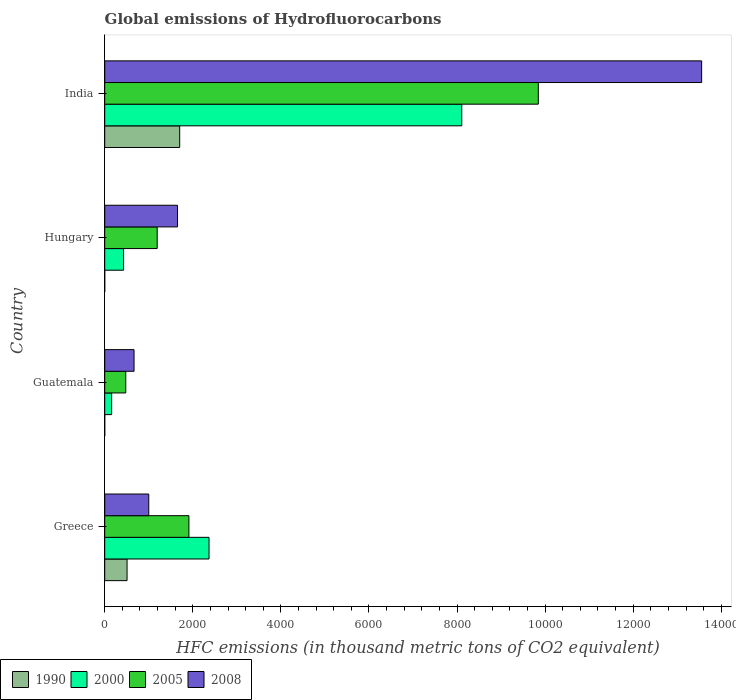How many bars are there on the 3rd tick from the top?
Offer a very short reply. 4. How many bars are there on the 2nd tick from the bottom?
Offer a terse response. 4. In how many cases, is the number of bars for a given country not equal to the number of legend labels?
Your answer should be very brief. 0. What is the global emissions of Hydrofluorocarbons in 2000 in Guatemala?
Offer a very short reply. 157.6. Across all countries, what is the maximum global emissions of Hydrofluorocarbons in 2008?
Keep it short and to the point. 1.36e+04. Across all countries, what is the minimum global emissions of Hydrofluorocarbons in 2005?
Your response must be concise. 477.8. In which country was the global emissions of Hydrofluorocarbons in 2008 maximum?
Give a very brief answer. India. In which country was the global emissions of Hydrofluorocarbons in 2000 minimum?
Offer a terse response. Guatemala. What is the total global emissions of Hydrofluorocarbons in 1990 in the graph?
Your response must be concise. 2209.5. What is the difference between the global emissions of Hydrofluorocarbons in 2005 in Hungary and that in India?
Keep it short and to the point. -8653.8. What is the difference between the global emissions of Hydrofluorocarbons in 2008 in Guatemala and the global emissions of Hydrofluorocarbons in 2000 in Hungary?
Provide a short and direct response. 237.6. What is the average global emissions of Hydrofluorocarbons in 2000 per country?
Offer a very short reply. 2765.35. What is the difference between the global emissions of Hydrofluorocarbons in 2000 and global emissions of Hydrofluorocarbons in 2005 in India?
Your response must be concise. -1738. In how many countries, is the global emissions of Hydrofluorocarbons in 2005 greater than 6000 thousand metric tons?
Your answer should be very brief. 1. What is the ratio of the global emissions of Hydrofluorocarbons in 2008 in Greece to that in Guatemala?
Your answer should be compact. 1.5. Is the global emissions of Hydrofluorocarbons in 1990 in Greece less than that in Hungary?
Make the answer very short. No. What is the difference between the highest and the second highest global emissions of Hydrofluorocarbons in 2000?
Offer a very short reply. 5738.8. What is the difference between the highest and the lowest global emissions of Hydrofluorocarbons in 2000?
Your answer should be very brief. 7949.6. In how many countries, is the global emissions of Hydrofluorocarbons in 2005 greater than the average global emissions of Hydrofluorocarbons in 2005 taken over all countries?
Ensure brevity in your answer.  1. Is the sum of the global emissions of Hydrofluorocarbons in 2005 in Greece and Guatemala greater than the maximum global emissions of Hydrofluorocarbons in 1990 across all countries?
Ensure brevity in your answer.  Yes. What does the 4th bar from the bottom in India represents?
Your response must be concise. 2008. Is it the case that in every country, the sum of the global emissions of Hydrofluorocarbons in 2005 and global emissions of Hydrofluorocarbons in 2008 is greater than the global emissions of Hydrofluorocarbons in 2000?
Give a very brief answer. Yes. How many bars are there?
Offer a terse response. 16. Are all the bars in the graph horizontal?
Your answer should be compact. Yes. How many countries are there in the graph?
Provide a short and direct response. 4. What is the difference between two consecutive major ticks on the X-axis?
Offer a very short reply. 2000. Are the values on the major ticks of X-axis written in scientific E-notation?
Make the answer very short. No. How many legend labels are there?
Ensure brevity in your answer.  4. How are the legend labels stacked?
Ensure brevity in your answer.  Horizontal. What is the title of the graph?
Offer a very short reply. Global emissions of Hydrofluorocarbons. What is the label or title of the X-axis?
Ensure brevity in your answer.  HFC emissions (in thousand metric tons of CO2 equivalent). What is the label or title of the Y-axis?
Your response must be concise. Country. What is the HFC emissions (in thousand metric tons of CO2 equivalent) in 1990 in Greece?
Your answer should be compact. 507.2. What is the HFC emissions (in thousand metric tons of CO2 equivalent) in 2000 in Greece?
Your answer should be very brief. 2368.4. What is the HFC emissions (in thousand metric tons of CO2 equivalent) in 2005 in Greece?
Provide a succinct answer. 1911.4. What is the HFC emissions (in thousand metric tons of CO2 equivalent) in 2008 in Greece?
Make the answer very short. 1000.3. What is the HFC emissions (in thousand metric tons of CO2 equivalent) of 1990 in Guatemala?
Provide a short and direct response. 0.1. What is the HFC emissions (in thousand metric tons of CO2 equivalent) in 2000 in Guatemala?
Keep it short and to the point. 157.6. What is the HFC emissions (in thousand metric tons of CO2 equivalent) in 2005 in Guatemala?
Your response must be concise. 477.8. What is the HFC emissions (in thousand metric tons of CO2 equivalent) in 2008 in Guatemala?
Make the answer very short. 665.8. What is the HFC emissions (in thousand metric tons of CO2 equivalent) of 2000 in Hungary?
Offer a terse response. 428.2. What is the HFC emissions (in thousand metric tons of CO2 equivalent) in 2005 in Hungary?
Keep it short and to the point. 1191.4. What is the HFC emissions (in thousand metric tons of CO2 equivalent) of 2008 in Hungary?
Your response must be concise. 1652.9. What is the HFC emissions (in thousand metric tons of CO2 equivalent) of 1990 in India?
Give a very brief answer. 1702.1. What is the HFC emissions (in thousand metric tons of CO2 equivalent) of 2000 in India?
Your answer should be very brief. 8107.2. What is the HFC emissions (in thousand metric tons of CO2 equivalent) of 2005 in India?
Your response must be concise. 9845.2. What is the HFC emissions (in thousand metric tons of CO2 equivalent) in 2008 in India?
Your answer should be compact. 1.36e+04. Across all countries, what is the maximum HFC emissions (in thousand metric tons of CO2 equivalent) in 1990?
Give a very brief answer. 1702.1. Across all countries, what is the maximum HFC emissions (in thousand metric tons of CO2 equivalent) of 2000?
Your response must be concise. 8107.2. Across all countries, what is the maximum HFC emissions (in thousand metric tons of CO2 equivalent) of 2005?
Your response must be concise. 9845.2. Across all countries, what is the maximum HFC emissions (in thousand metric tons of CO2 equivalent) in 2008?
Offer a terse response. 1.36e+04. Across all countries, what is the minimum HFC emissions (in thousand metric tons of CO2 equivalent) in 2000?
Your answer should be very brief. 157.6. Across all countries, what is the minimum HFC emissions (in thousand metric tons of CO2 equivalent) in 2005?
Offer a very short reply. 477.8. Across all countries, what is the minimum HFC emissions (in thousand metric tons of CO2 equivalent) in 2008?
Offer a very short reply. 665.8. What is the total HFC emissions (in thousand metric tons of CO2 equivalent) of 1990 in the graph?
Your answer should be compact. 2209.5. What is the total HFC emissions (in thousand metric tons of CO2 equivalent) in 2000 in the graph?
Your response must be concise. 1.11e+04. What is the total HFC emissions (in thousand metric tons of CO2 equivalent) in 2005 in the graph?
Ensure brevity in your answer.  1.34e+04. What is the total HFC emissions (in thousand metric tons of CO2 equivalent) in 2008 in the graph?
Provide a short and direct response. 1.69e+04. What is the difference between the HFC emissions (in thousand metric tons of CO2 equivalent) of 1990 in Greece and that in Guatemala?
Offer a very short reply. 507.1. What is the difference between the HFC emissions (in thousand metric tons of CO2 equivalent) of 2000 in Greece and that in Guatemala?
Offer a very short reply. 2210.8. What is the difference between the HFC emissions (in thousand metric tons of CO2 equivalent) of 2005 in Greece and that in Guatemala?
Your answer should be very brief. 1433.6. What is the difference between the HFC emissions (in thousand metric tons of CO2 equivalent) of 2008 in Greece and that in Guatemala?
Keep it short and to the point. 334.5. What is the difference between the HFC emissions (in thousand metric tons of CO2 equivalent) in 1990 in Greece and that in Hungary?
Offer a very short reply. 507.1. What is the difference between the HFC emissions (in thousand metric tons of CO2 equivalent) in 2000 in Greece and that in Hungary?
Ensure brevity in your answer.  1940.2. What is the difference between the HFC emissions (in thousand metric tons of CO2 equivalent) of 2005 in Greece and that in Hungary?
Your answer should be very brief. 720. What is the difference between the HFC emissions (in thousand metric tons of CO2 equivalent) in 2008 in Greece and that in Hungary?
Offer a very short reply. -652.6. What is the difference between the HFC emissions (in thousand metric tons of CO2 equivalent) in 1990 in Greece and that in India?
Your response must be concise. -1194.9. What is the difference between the HFC emissions (in thousand metric tons of CO2 equivalent) of 2000 in Greece and that in India?
Ensure brevity in your answer.  -5738.8. What is the difference between the HFC emissions (in thousand metric tons of CO2 equivalent) of 2005 in Greece and that in India?
Give a very brief answer. -7933.8. What is the difference between the HFC emissions (in thousand metric tons of CO2 equivalent) of 2008 in Greece and that in India?
Offer a terse response. -1.26e+04. What is the difference between the HFC emissions (in thousand metric tons of CO2 equivalent) of 1990 in Guatemala and that in Hungary?
Provide a succinct answer. 0. What is the difference between the HFC emissions (in thousand metric tons of CO2 equivalent) in 2000 in Guatemala and that in Hungary?
Make the answer very short. -270.6. What is the difference between the HFC emissions (in thousand metric tons of CO2 equivalent) of 2005 in Guatemala and that in Hungary?
Offer a very short reply. -713.6. What is the difference between the HFC emissions (in thousand metric tons of CO2 equivalent) in 2008 in Guatemala and that in Hungary?
Your response must be concise. -987.1. What is the difference between the HFC emissions (in thousand metric tons of CO2 equivalent) of 1990 in Guatemala and that in India?
Provide a short and direct response. -1702. What is the difference between the HFC emissions (in thousand metric tons of CO2 equivalent) of 2000 in Guatemala and that in India?
Make the answer very short. -7949.6. What is the difference between the HFC emissions (in thousand metric tons of CO2 equivalent) of 2005 in Guatemala and that in India?
Provide a succinct answer. -9367.4. What is the difference between the HFC emissions (in thousand metric tons of CO2 equivalent) in 2008 in Guatemala and that in India?
Provide a succinct answer. -1.29e+04. What is the difference between the HFC emissions (in thousand metric tons of CO2 equivalent) of 1990 in Hungary and that in India?
Ensure brevity in your answer.  -1702. What is the difference between the HFC emissions (in thousand metric tons of CO2 equivalent) in 2000 in Hungary and that in India?
Make the answer very short. -7679. What is the difference between the HFC emissions (in thousand metric tons of CO2 equivalent) of 2005 in Hungary and that in India?
Keep it short and to the point. -8653.8. What is the difference between the HFC emissions (in thousand metric tons of CO2 equivalent) of 2008 in Hungary and that in India?
Keep it short and to the point. -1.19e+04. What is the difference between the HFC emissions (in thousand metric tons of CO2 equivalent) of 1990 in Greece and the HFC emissions (in thousand metric tons of CO2 equivalent) of 2000 in Guatemala?
Keep it short and to the point. 349.6. What is the difference between the HFC emissions (in thousand metric tons of CO2 equivalent) in 1990 in Greece and the HFC emissions (in thousand metric tons of CO2 equivalent) in 2005 in Guatemala?
Make the answer very short. 29.4. What is the difference between the HFC emissions (in thousand metric tons of CO2 equivalent) of 1990 in Greece and the HFC emissions (in thousand metric tons of CO2 equivalent) of 2008 in Guatemala?
Keep it short and to the point. -158.6. What is the difference between the HFC emissions (in thousand metric tons of CO2 equivalent) in 2000 in Greece and the HFC emissions (in thousand metric tons of CO2 equivalent) in 2005 in Guatemala?
Keep it short and to the point. 1890.6. What is the difference between the HFC emissions (in thousand metric tons of CO2 equivalent) in 2000 in Greece and the HFC emissions (in thousand metric tons of CO2 equivalent) in 2008 in Guatemala?
Your answer should be compact. 1702.6. What is the difference between the HFC emissions (in thousand metric tons of CO2 equivalent) of 2005 in Greece and the HFC emissions (in thousand metric tons of CO2 equivalent) of 2008 in Guatemala?
Provide a succinct answer. 1245.6. What is the difference between the HFC emissions (in thousand metric tons of CO2 equivalent) in 1990 in Greece and the HFC emissions (in thousand metric tons of CO2 equivalent) in 2000 in Hungary?
Ensure brevity in your answer.  79. What is the difference between the HFC emissions (in thousand metric tons of CO2 equivalent) in 1990 in Greece and the HFC emissions (in thousand metric tons of CO2 equivalent) in 2005 in Hungary?
Your response must be concise. -684.2. What is the difference between the HFC emissions (in thousand metric tons of CO2 equivalent) in 1990 in Greece and the HFC emissions (in thousand metric tons of CO2 equivalent) in 2008 in Hungary?
Ensure brevity in your answer.  -1145.7. What is the difference between the HFC emissions (in thousand metric tons of CO2 equivalent) in 2000 in Greece and the HFC emissions (in thousand metric tons of CO2 equivalent) in 2005 in Hungary?
Offer a terse response. 1177. What is the difference between the HFC emissions (in thousand metric tons of CO2 equivalent) of 2000 in Greece and the HFC emissions (in thousand metric tons of CO2 equivalent) of 2008 in Hungary?
Ensure brevity in your answer.  715.5. What is the difference between the HFC emissions (in thousand metric tons of CO2 equivalent) of 2005 in Greece and the HFC emissions (in thousand metric tons of CO2 equivalent) of 2008 in Hungary?
Keep it short and to the point. 258.5. What is the difference between the HFC emissions (in thousand metric tons of CO2 equivalent) of 1990 in Greece and the HFC emissions (in thousand metric tons of CO2 equivalent) of 2000 in India?
Your answer should be very brief. -7600. What is the difference between the HFC emissions (in thousand metric tons of CO2 equivalent) of 1990 in Greece and the HFC emissions (in thousand metric tons of CO2 equivalent) of 2005 in India?
Provide a succinct answer. -9338. What is the difference between the HFC emissions (in thousand metric tons of CO2 equivalent) in 1990 in Greece and the HFC emissions (in thousand metric tons of CO2 equivalent) in 2008 in India?
Give a very brief answer. -1.30e+04. What is the difference between the HFC emissions (in thousand metric tons of CO2 equivalent) of 2000 in Greece and the HFC emissions (in thousand metric tons of CO2 equivalent) of 2005 in India?
Ensure brevity in your answer.  -7476.8. What is the difference between the HFC emissions (in thousand metric tons of CO2 equivalent) of 2000 in Greece and the HFC emissions (in thousand metric tons of CO2 equivalent) of 2008 in India?
Give a very brief answer. -1.12e+04. What is the difference between the HFC emissions (in thousand metric tons of CO2 equivalent) in 2005 in Greece and the HFC emissions (in thousand metric tons of CO2 equivalent) in 2008 in India?
Keep it short and to the point. -1.16e+04. What is the difference between the HFC emissions (in thousand metric tons of CO2 equivalent) of 1990 in Guatemala and the HFC emissions (in thousand metric tons of CO2 equivalent) of 2000 in Hungary?
Provide a succinct answer. -428.1. What is the difference between the HFC emissions (in thousand metric tons of CO2 equivalent) of 1990 in Guatemala and the HFC emissions (in thousand metric tons of CO2 equivalent) of 2005 in Hungary?
Ensure brevity in your answer.  -1191.3. What is the difference between the HFC emissions (in thousand metric tons of CO2 equivalent) in 1990 in Guatemala and the HFC emissions (in thousand metric tons of CO2 equivalent) in 2008 in Hungary?
Your answer should be compact. -1652.8. What is the difference between the HFC emissions (in thousand metric tons of CO2 equivalent) of 2000 in Guatemala and the HFC emissions (in thousand metric tons of CO2 equivalent) of 2005 in Hungary?
Make the answer very short. -1033.8. What is the difference between the HFC emissions (in thousand metric tons of CO2 equivalent) of 2000 in Guatemala and the HFC emissions (in thousand metric tons of CO2 equivalent) of 2008 in Hungary?
Ensure brevity in your answer.  -1495.3. What is the difference between the HFC emissions (in thousand metric tons of CO2 equivalent) in 2005 in Guatemala and the HFC emissions (in thousand metric tons of CO2 equivalent) in 2008 in Hungary?
Ensure brevity in your answer.  -1175.1. What is the difference between the HFC emissions (in thousand metric tons of CO2 equivalent) in 1990 in Guatemala and the HFC emissions (in thousand metric tons of CO2 equivalent) in 2000 in India?
Provide a short and direct response. -8107.1. What is the difference between the HFC emissions (in thousand metric tons of CO2 equivalent) in 1990 in Guatemala and the HFC emissions (in thousand metric tons of CO2 equivalent) in 2005 in India?
Your response must be concise. -9845.1. What is the difference between the HFC emissions (in thousand metric tons of CO2 equivalent) in 1990 in Guatemala and the HFC emissions (in thousand metric tons of CO2 equivalent) in 2008 in India?
Keep it short and to the point. -1.36e+04. What is the difference between the HFC emissions (in thousand metric tons of CO2 equivalent) in 2000 in Guatemala and the HFC emissions (in thousand metric tons of CO2 equivalent) in 2005 in India?
Ensure brevity in your answer.  -9687.6. What is the difference between the HFC emissions (in thousand metric tons of CO2 equivalent) in 2000 in Guatemala and the HFC emissions (in thousand metric tons of CO2 equivalent) in 2008 in India?
Provide a succinct answer. -1.34e+04. What is the difference between the HFC emissions (in thousand metric tons of CO2 equivalent) of 2005 in Guatemala and the HFC emissions (in thousand metric tons of CO2 equivalent) of 2008 in India?
Your response must be concise. -1.31e+04. What is the difference between the HFC emissions (in thousand metric tons of CO2 equivalent) in 1990 in Hungary and the HFC emissions (in thousand metric tons of CO2 equivalent) in 2000 in India?
Your answer should be compact. -8107.1. What is the difference between the HFC emissions (in thousand metric tons of CO2 equivalent) in 1990 in Hungary and the HFC emissions (in thousand metric tons of CO2 equivalent) in 2005 in India?
Offer a terse response. -9845.1. What is the difference between the HFC emissions (in thousand metric tons of CO2 equivalent) in 1990 in Hungary and the HFC emissions (in thousand metric tons of CO2 equivalent) in 2008 in India?
Provide a succinct answer. -1.36e+04. What is the difference between the HFC emissions (in thousand metric tons of CO2 equivalent) in 2000 in Hungary and the HFC emissions (in thousand metric tons of CO2 equivalent) in 2005 in India?
Your response must be concise. -9417. What is the difference between the HFC emissions (in thousand metric tons of CO2 equivalent) in 2000 in Hungary and the HFC emissions (in thousand metric tons of CO2 equivalent) in 2008 in India?
Ensure brevity in your answer.  -1.31e+04. What is the difference between the HFC emissions (in thousand metric tons of CO2 equivalent) in 2005 in Hungary and the HFC emissions (in thousand metric tons of CO2 equivalent) in 2008 in India?
Your response must be concise. -1.24e+04. What is the average HFC emissions (in thousand metric tons of CO2 equivalent) of 1990 per country?
Give a very brief answer. 552.38. What is the average HFC emissions (in thousand metric tons of CO2 equivalent) in 2000 per country?
Keep it short and to the point. 2765.35. What is the average HFC emissions (in thousand metric tons of CO2 equivalent) of 2005 per country?
Your answer should be very brief. 3356.45. What is the average HFC emissions (in thousand metric tons of CO2 equivalent) of 2008 per country?
Your answer should be very brief. 4218.18. What is the difference between the HFC emissions (in thousand metric tons of CO2 equivalent) of 1990 and HFC emissions (in thousand metric tons of CO2 equivalent) of 2000 in Greece?
Your response must be concise. -1861.2. What is the difference between the HFC emissions (in thousand metric tons of CO2 equivalent) in 1990 and HFC emissions (in thousand metric tons of CO2 equivalent) in 2005 in Greece?
Make the answer very short. -1404.2. What is the difference between the HFC emissions (in thousand metric tons of CO2 equivalent) in 1990 and HFC emissions (in thousand metric tons of CO2 equivalent) in 2008 in Greece?
Keep it short and to the point. -493.1. What is the difference between the HFC emissions (in thousand metric tons of CO2 equivalent) of 2000 and HFC emissions (in thousand metric tons of CO2 equivalent) of 2005 in Greece?
Offer a terse response. 457. What is the difference between the HFC emissions (in thousand metric tons of CO2 equivalent) in 2000 and HFC emissions (in thousand metric tons of CO2 equivalent) in 2008 in Greece?
Give a very brief answer. 1368.1. What is the difference between the HFC emissions (in thousand metric tons of CO2 equivalent) in 2005 and HFC emissions (in thousand metric tons of CO2 equivalent) in 2008 in Greece?
Provide a short and direct response. 911.1. What is the difference between the HFC emissions (in thousand metric tons of CO2 equivalent) in 1990 and HFC emissions (in thousand metric tons of CO2 equivalent) in 2000 in Guatemala?
Keep it short and to the point. -157.5. What is the difference between the HFC emissions (in thousand metric tons of CO2 equivalent) of 1990 and HFC emissions (in thousand metric tons of CO2 equivalent) of 2005 in Guatemala?
Your answer should be compact. -477.7. What is the difference between the HFC emissions (in thousand metric tons of CO2 equivalent) in 1990 and HFC emissions (in thousand metric tons of CO2 equivalent) in 2008 in Guatemala?
Make the answer very short. -665.7. What is the difference between the HFC emissions (in thousand metric tons of CO2 equivalent) of 2000 and HFC emissions (in thousand metric tons of CO2 equivalent) of 2005 in Guatemala?
Make the answer very short. -320.2. What is the difference between the HFC emissions (in thousand metric tons of CO2 equivalent) in 2000 and HFC emissions (in thousand metric tons of CO2 equivalent) in 2008 in Guatemala?
Your response must be concise. -508.2. What is the difference between the HFC emissions (in thousand metric tons of CO2 equivalent) in 2005 and HFC emissions (in thousand metric tons of CO2 equivalent) in 2008 in Guatemala?
Your answer should be compact. -188. What is the difference between the HFC emissions (in thousand metric tons of CO2 equivalent) of 1990 and HFC emissions (in thousand metric tons of CO2 equivalent) of 2000 in Hungary?
Provide a short and direct response. -428.1. What is the difference between the HFC emissions (in thousand metric tons of CO2 equivalent) of 1990 and HFC emissions (in thousand metric tons of CO2 equivalent) of 2005 in Hungary?
Ensure brevity in your answer.  -1191.3. What is the difference between the HFC emissions (in thousand metric tons of CO2 equivalent) of 1990 and HFC emissions (in thousand metric tons of CO2 equivalent) of 2008 in Hungary?
Ensure brevity in your answer.  -1652.8. What is the difference between the HFC emissions (in thousand metric tons of CO2 equivalent) of 2000 and HFC emissions (in thousand metric tons of CO2 equivalent) of 2005 in Hungary?
Keep it short and to the point. -763.2. What is the difference between the HFC emissions (in thousand metric tons of CO2 equivalent) in 2000 and HFC emissions (in thousand metric tons of CO2 equivalent) in 2008 in Hungary?
Keep it short and to the point. -1224.7. What is the difference between the HFC emissions (in thousand metric tons of CO2 equivalent) in 2005 and HFC emissions (in thousand metric tons of CO2 equivalent) in 2008 in Hungary?
Ensure brevity in your answer.  -461.5. What is the difference between the HFC emissions (in thousand metric tons of CO2 equivalent) of 1990 and HFC emissions (in thousand metric tons of CO2 equivalent) of 2000 in India?
Provide a succinct answer. -6405.1. What is the difference between the HFC emissions (in thousand metric tons of CO2 equivalent) in 1990 and HFC emissions (in thousand metric tons of CO2 equivalent) in 2005 in India?
Give a very brief answer. -8143.1. What is the difference between the HFC emissions (in thousand metric tons of CO2 equivalent) in 1990 and HFC emissions (in thousand metric tons of CO2 equivalent) in 2008 in India?
Keep it short and to the point. -1.19e+04. What is the difference between the HFC emissions (in thousand metric tons of CO2 equivalent) in 2000 and HFC emissions (in thousand metric tons of CO2 equivalent) in 2005 in India?
Keep it short and to the point. -1738. What is the difference between the HFC emissions (in thousand metric tons of CO2 equivalent) in 2000 and HFC emissions (in thousand metric tons of CO2 equivalent) in 2008 in India?
Make the answer very short. -5446.5. What is the difference between the HFC emissions (in thousand metric tons of CO2 equivalent) of 2005 and HFC emissions (in thousand metric tons of CO2 equivalent) of 2008 in India?
Your answer should be compact. -3708.5. What is the ratio of the HFC emissions (in thousand metric tons of CO2 equivalent) in 1990 in Greece to that in Guatemala?
Provide a succinct answer. 5072. What is the ratio of the HFC emissions (in thousand metric tons of CO2 equivalent) of 2000 in Greece to that in Guatemala?
Keep it short and to the point. 15.03. What is the ratio of the HFC emissions (in thousand metric tons of CO2 equivalent) in 2005 in Greece to that in Guatemala?
Your answer should be very brief. 4. What is the ratio of the HFC emissions (in thousand metric tons of CO2 equivalent) in 2008 in Greece to that in Guatemala?
Your answer should be compact. 1.5. What is the ratio of the HFC emissions (in thousand metric tons of CO2 equivalent) of 1990 in Greece to that in Hungary?
Make the answer very short. 5072. What is the ratio of the HFC emissions (in thousand metric tons of CO2 equivalent) of 2000 in Greece to that in Hungary?
Ensure brevity in your answer.  5.53. What is the ratio of the HFC emissions (in thousand metric tons of CO2 equivalent) in 2005 in Greece to that in Hungary?
Your answer should be very brief. 1.6. What is the ratio of the HFC emissions (in thousand metric tons of CO2 equivalent) of 2008 in Greece to that in Hungary?
Make the answer very short. 0.61. What is the ratio of the HFC emissions (in thousand metric tons of CO2 equivalent) of 1990 in Greece to that in India?
Provide a short and direct response. 0.3. What is the ratio of the HFC emissions (in thousand metric tons of CO2 equivalent) of 2000 in Greece to that in India?
Offer a very short reply. 0.29. What is the ratio of the HFC emissions (in thousand metric tons of CO2 equivalent) in 2005 in Greece to that in India?
Keep it short and to the point. 0.19. What is the ratio of the HFC emissions (in thousand metric tons of CO2 equivalent) of 2008 in Greece to that in India?
Give a very brief answer. 0.07. What is the ratio of the HFC emissions (in thousand metric tons of CO2 equivalent) of 2000 in Guatemala to that in Hungary?
Provide a short and direct response. 0.37. What is the ratio of the HFC emissions (in thousand metric tons of CO2 equivalent) in 2005 in Guatemala to that in Hungary?
Your response must be concise. 0.4. What is the ratio of the HFC emissions (in thousand metric tons of CO2 equivalent) in 2008 in Guatemala to that in Hungary?
Your answer should be compact. 0.4. What is the ratio of the HFC emissions (in thousand metric tons of CO2 equivalent) in 1990 in Guatemala to that in India?
Ensure brevity in your answer.  0. What is the ratio of the HFC emissions (in thousand metric tons of CO2 equivalent) in 2000 in Guatemala to that in India?
Provide a short and direct response. 0.02. What is the ratio of the HFC emissions (in thousand metric tons of CO2 equivalent) of 2005 in Guatemala to that in India?
Your answer should be compact. 0.05. What is the ratio of the HFC emissions (in thousand metric tons of CO2 equivalent) in 2008 in Guatemala to that in India?
Make the answer very short. 0.05. What is the ratio of the HFC emissions (in thousand metric tons of CO2 equivalent) of 2000 in Hungary to that in India?
Your response must be concise. 0.05. What is the ratio of the HFC emissions (in thousand metric tons of CO2 equivalent) in 2005 in Hungary to that in India?
Offer a terse response. 0.12. What is the ratio of the HFC emissions (in thousand metric tons of CO2 equivalent) of 2008 in Hungary to that in India?
Offer a very short reply. 0.12. What is the difference between the highest and the second highest HFC emissions (in thousand metric tons of CO2 equivalent) of 1990?
Offer a terse response. 1194.9. What is the difference between the highest and the second highest HFC emissions (in thousand metric tons of CO2 equivalent) of 2000?
Your answer should be compact. 5738.8. What is the difference between the highest and the second highest HFC emissions (in thousand metric tons of CO2 equivalent) in 2005?
Provide a succinct answer. 7933.8. What is the difference between the highest and the second highest HFC emissions (in thousand metric tons of CO2 equivalent) in 2008?
Provide a succinct answer. 1.19e+04. What is the difference between the highest and the lowest HFC emissions (in thousand metric tons of CO2 equivalent) in 1990?
Provide a short and direct response. 1702. What is the difference between the highest and the lowest HFC emissions (in thousand metric tons of CO2 equivalent) of 2000?
Ensure brevity in your answer.  7949.6. What is the difference between the highest and the lowest HFC emissions (in thousand metric tons of CO2 equivalent) in 2005?
Your response must be concise. 9367.4. What is the difference between the highest and the lowest HFC emissions (in thousand metric tons of CO2 equivalent) in 2008?
Give a very brief answer. 1.29e+04. 